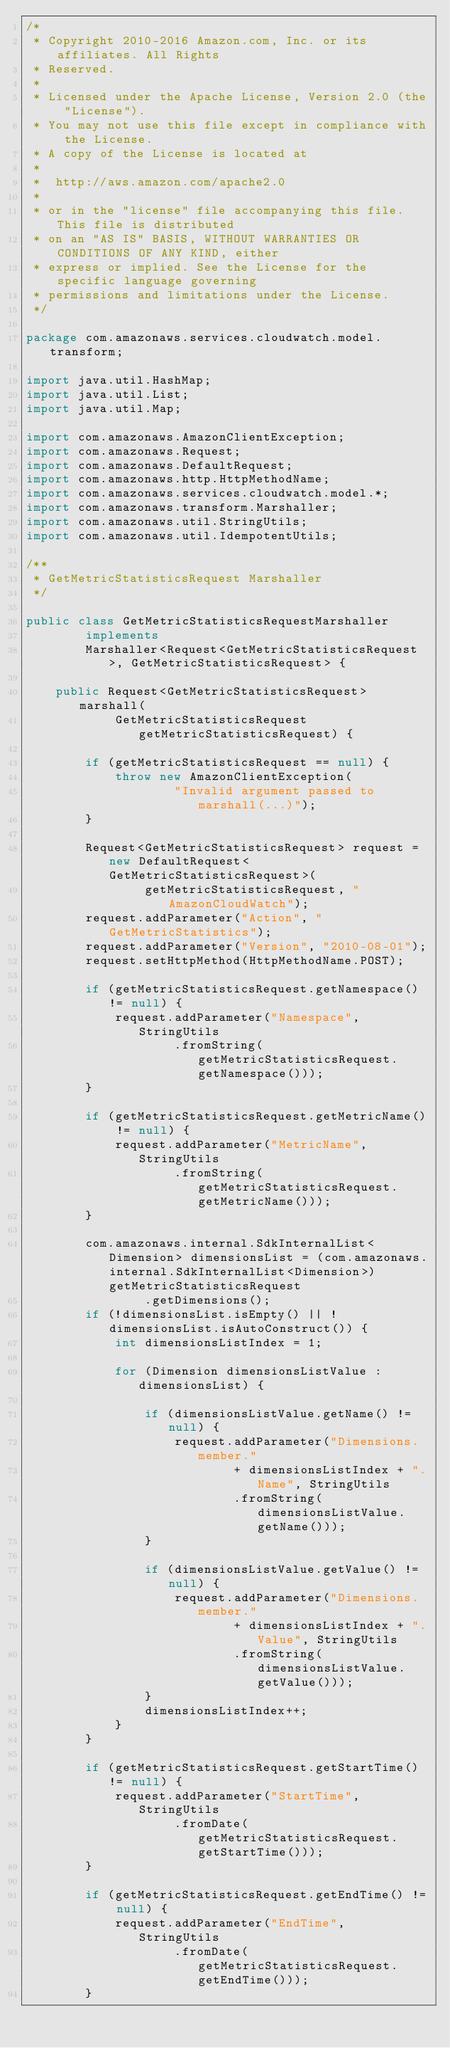<code> <loc_0><loc_0><loc_500><loc_500><_Java_>/*
 * Copyright 2010-2016 Amazon.com, Inc. or its affiliates. All Rights
 * Reserved.
 *
 * Licensed under the Apache License, Version 2.0 (the "License").
 * You may not use this file except in compliance with the License.
 * A copy of the License is located at
 *
 *  http://aws.amazon.com/apache2.0
 *
 * or in the "license" file accompanying this file. This file is distributed
 * on an "AS IS" BASIS, WITHOUT WARRANTIES OR CONDITIONS OF ANY KIND, either
 * express or implied. See the License for the specific language governing
 * permissions and limitations under the License.
 */

package com.amazonaws.services.cloudwatch.model.transform;

import java.util.HashMap;
import java.util.List;
import java.util.Map;

import com.amazonaws.AmazonClientException;
import com.amazonaws.Request;
import com.amazonaws.DefaultRequest;
import com.amazonaws.http.HttpMethodName;
import com.amazonaws.services.cloudwatch.model.*;
import com.amazonaws.transform.Marshaller;
import com.amazonaws.util.StringUtils;
import com.amazonaws.util.IdempotentUtils;

/**
 * GetMetricStatisticsRequest Marshaller
 */

public class GetMetricStatisticsRequestMarshaller
        implements
        Marshaller<Request<GetMetricStatisticsRequest>, GetMetricStatisticsRequest> {

    public Request<GetMetricStatisticsRequest> marshall(
            GetMetricStatisticsRequest getMetricStatisticsRequest) {

        if (getMetricStatisticsRequest == null) {
            throw new AmazonClientException(
                    "Invalid argument passed to marshall(...)");
        }

        Request<GetMetricStatisticsRequest> request = new DefaultRequest<GetMetricStatisticsRequest>(
                getMetricStatisticsRequest, "AmazonCloudWatch");
        request.addParameter("Action", "GetMetricStatistics");
        request.addParameter("Version", "2010-08-01");
        request.setHttpMethod(HttpMethodName.POST);

        if (getMetricStatisticsRequest.getNamespace() != null) {
            request.addParameter("Namespace", StringUtils
                    .fromString(getMetricStatisticsRequest.getNamespace()));
        }

        if (getMetricStatisticsRequest.getMetricName() != null) {
            request.addParameter("MetricName", StringUtils
                    .fromString(getMetricStatisticsRequest.getMetricName()));
        }

        com.amazonaws.internal.SdkInternalList<Dimension> dimensionsList = (com.amazonaws.internal.SdkInternalList<Dimension>) getMetricStatisticsRequest
                .getDimensions();
        if (!dimensionsList.isEmpty() || !dimensionsList.isAutoConstruct()) {
            int dimensionsListIndex = 1;

            for (Dimension dimensionsListValue : dimensionsList) {

                if (dimensionsListValue.getName() != null) {
                    request.addParameter("Dimensions.member."
                            + dimensionsListIndex + ".Name", StringUtils
                            .fromString(dimensionsListValue.getName()));
                }

                if (dimensionsListValue.getValue() != null) {
                    request.addParameter("Dimensions.member."
                            + dimensionsListIndex + ".Value", StringUtils
                            .fromString(dimensionsListValue.getValue()));
                }
                dimensionsListIndex++;
            }
        }

        if (getMetricStatisticsRequest.getStartTime() != null) {
            request.addParameter("StartTime", StringUtils
                    .fromDate(getMetricStatisticsRequest.getStartTime()));
        }

        if (getMetricStatisticsRequest.getEndTime() != null) {
            request.addParameter("EndTime", StringUtils
                    .fromDate(getMetricStatisticsRequest.getEndTime()));
        }
</code> 